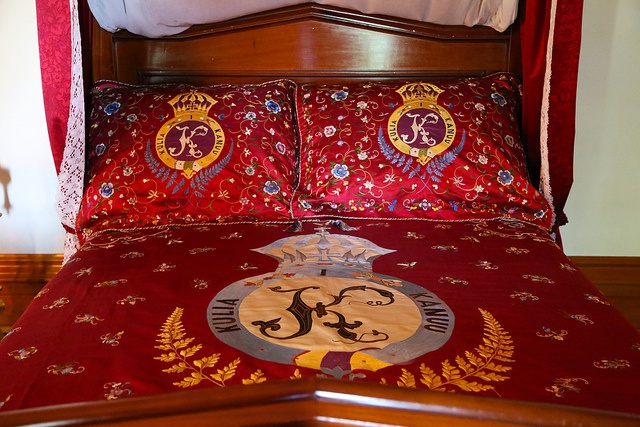Describe the objects in this image and their specific colors. I can see a bed in maroon, lightgray, black, and brown tones in this image. 